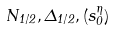Convert formula to latex. <formula><loc_0><loc_0><loc_500><loc_500>N _ { 1 / 2 } , \Delta _ { 1 / 2 } , ( s ^ { \eta } _ { 0 } )</formula> 